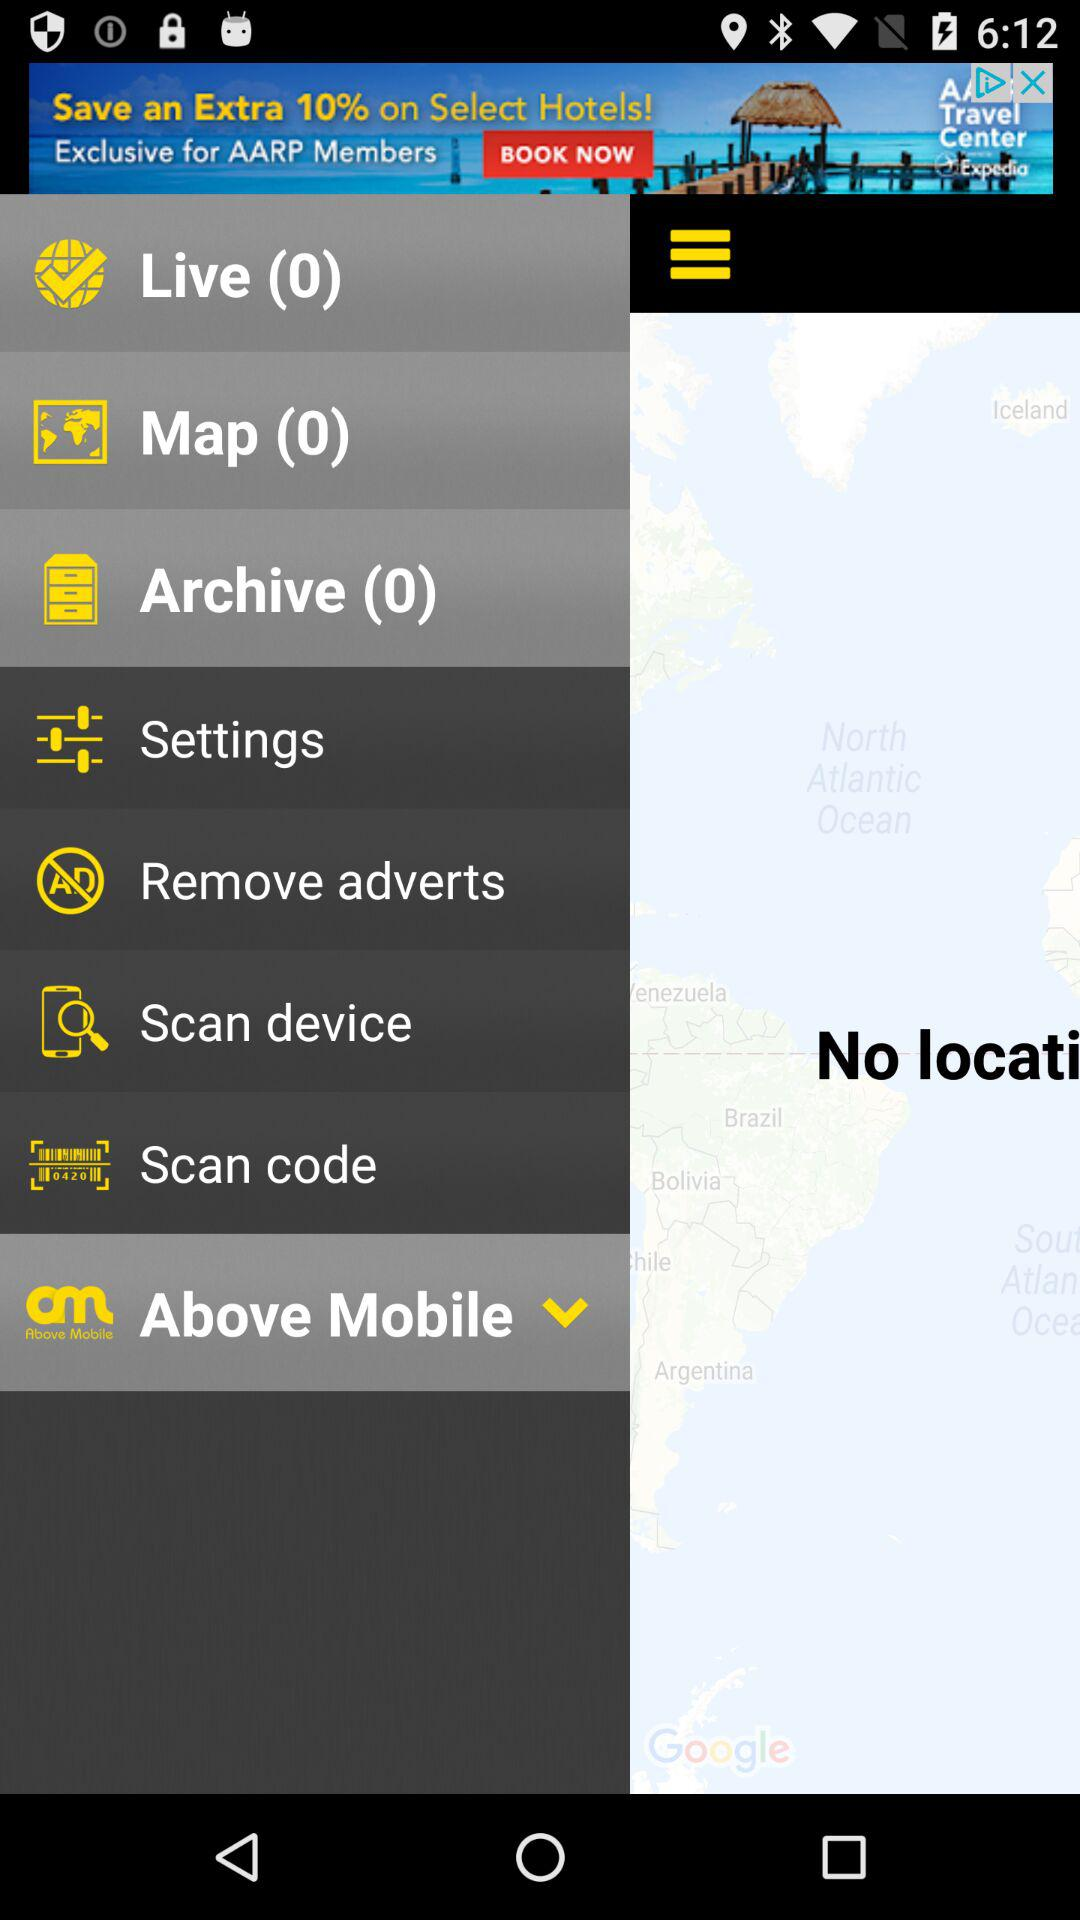What is the number of items in "Map"? The number of items in "Map" is 0. 